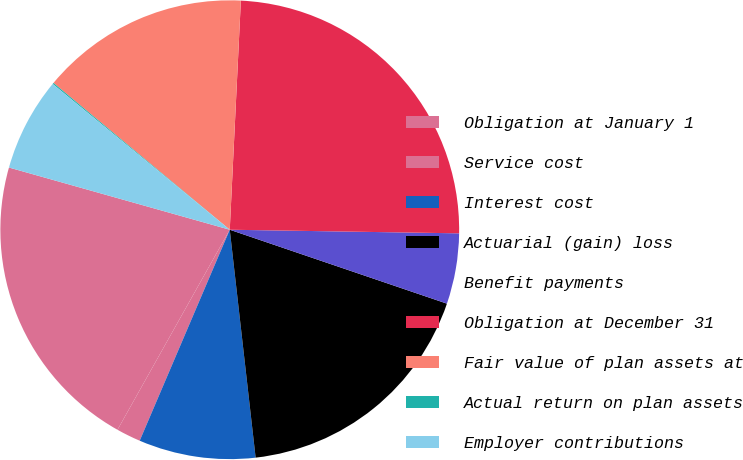Convert chart. <chart><loc_0><loc_0><loc_500><loc_500><pie_chart><fcel>Obligation at January 1<fcel>Service cost<fcel>Interest cost<fcel>Actuarial (gain) loss<fcel>Benefit payments<fcel>Obligation at December 31<fcel>Fair value of plan assets at<fcel>Actual return on plan assets<fcel>Employer contributions<nl><fcel>21.23%<fcel>1.72%<fcel>8.22%<fcel>17.98%<fcel>4.97%<fcel>24.48%<fcel>14.72%<fcel>0.09%<fcel>6.59%<nl></chart> 